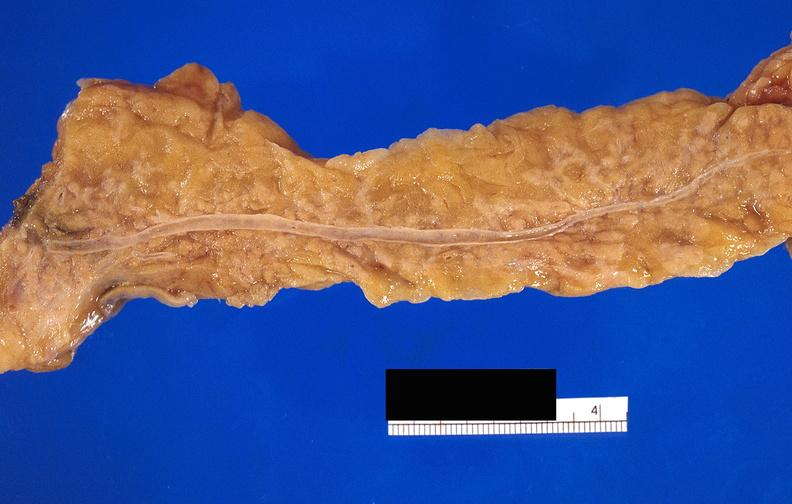what does this image show?
Answer the question using a single word or phrase. Pancreatic fat necrosis 